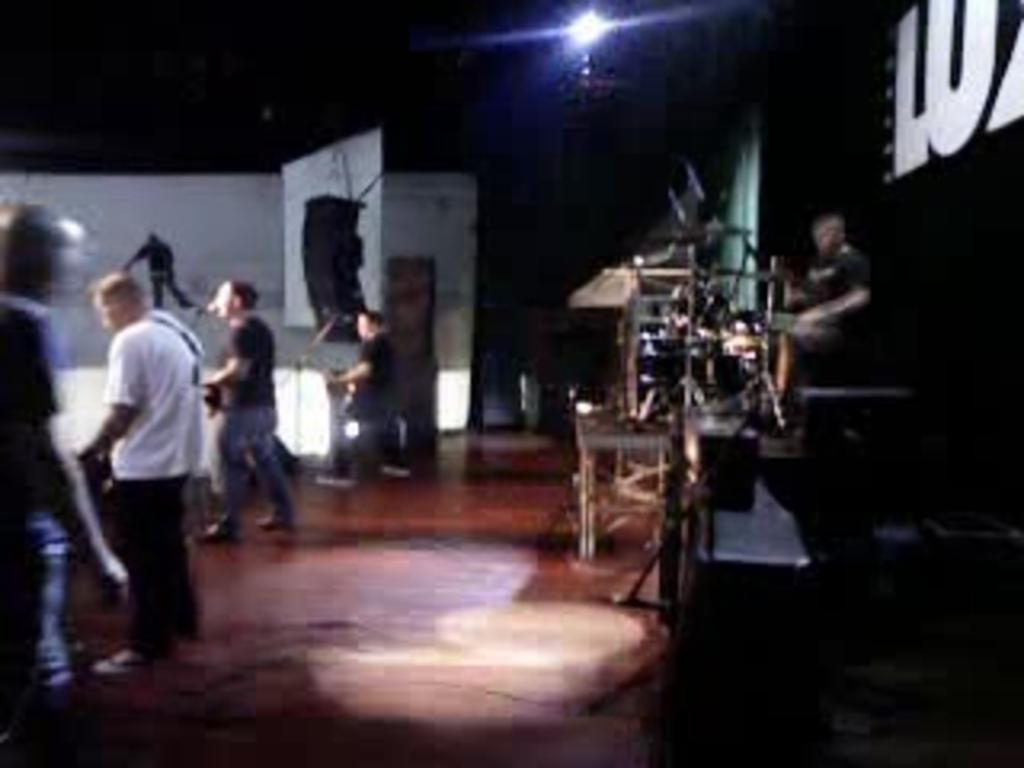What are the people in the image doing? There is a group of people standing on the floor, which suggests they might be participating in an activity or event. What is the position of the man in the image? There is a man sitting, which indicates he might be taking a break or observing the activity. What can be inferred about the presence of musical instruments in the image? Musical instruments are present, which suggests that music might be involved in the activity or event. Can you describe the lighting in the image? There is light in the image, which allows us to see the people, objects, and musical instruments clearly. What are some of the objects present in the image? There are some objects in the image, but their specific nature is not mentioned in the facts. How would you describe the background of the image? The background of the image is dark, which could create a contrast with the light in the foreground. How many ladybugs can be seen crawling on the musical instruments in the image? There are no ladybugs present in the image; it only mentions the presence of musical instruments. What caused the rice to spill on the floor in the image? There is no mention of rice in the image or any indication of a spill. 